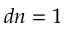<formula> <loc_0><loc_0><loc_500><loc_500>d n = 1</formula> 